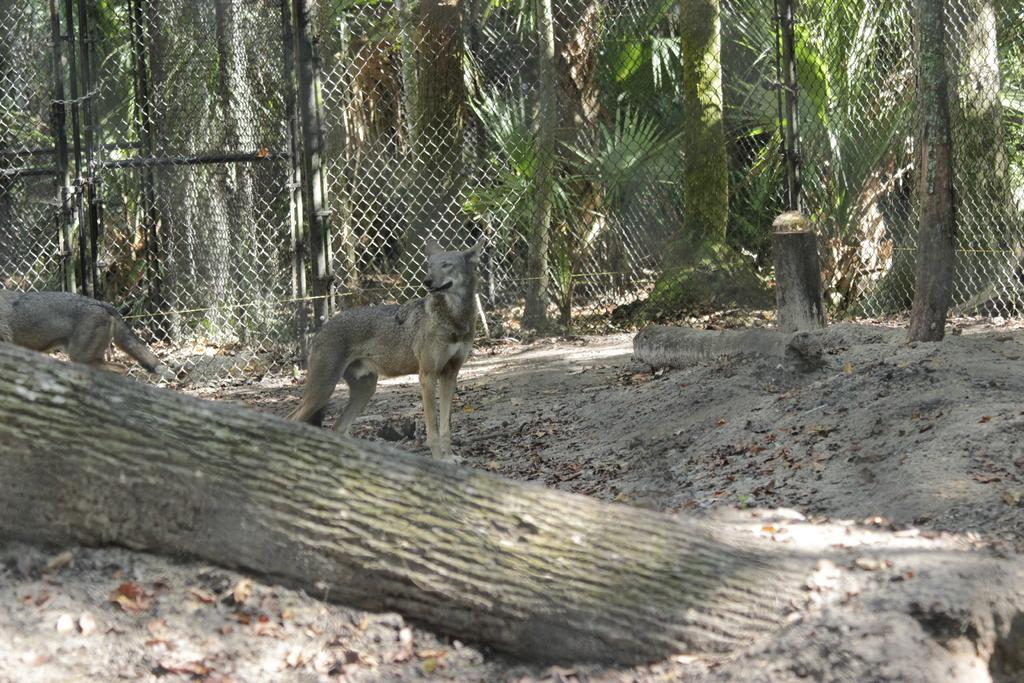Can you describe this image briefly? In this image we can see the animals on the ground. And there is a tree trunk. In the background, we can see the trees and fence. 